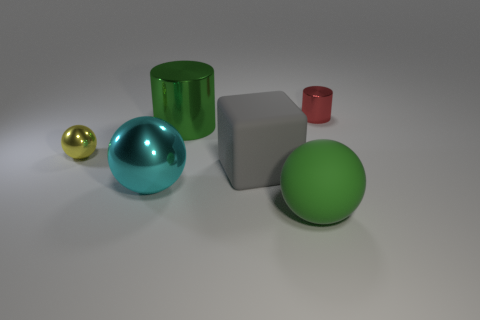Are there any other things that have the same shape as the gray rubber object?
Provide a short and direct response. No. What shape is the matte thing that is the same size as the gray rubber cube?
Offer a very short reply. Sphere. There is a small thing to the right of the small object left of the cylinder left of the tiny red metal cylinder; what is its shape?
Your response must be concise. Cylinder. Are there the same number of objects behind the big green ball and purple matte cylinders?
Your response must be concise. No. Does the red thing have the same size as the rubber ball?
Offer a terse response. No. How many matte things are small cyan objects or tiny yellow objects?
Provide a succinct answer. 0. What is the material of the green sphere that is the same size as the cyan ball?
Your answer should be very brief. Rubber. What number of other things are made of the same material as the big cyan ball?
Offer a very short reply. 3. Are there fewer large matte things that are behind the large green metal object than large green metal objects?
Your answer should be compact. Yes. Is the shape of the green metallic object the same as the red metallic object?
Your answer should be very brief. Yes. 